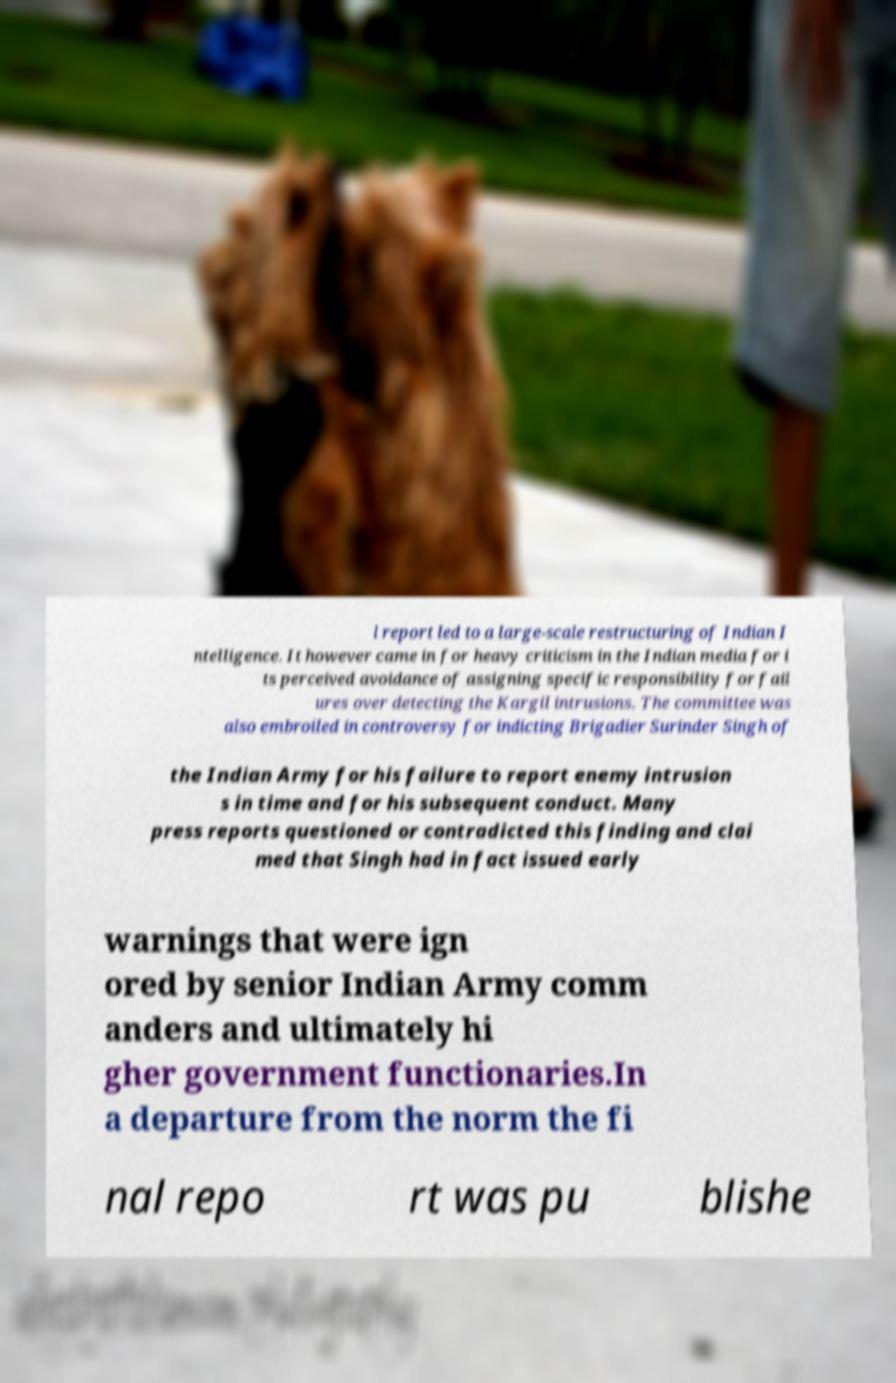I need the written content from this picture converted into text. Can you do that? l report led to a large-scale restructuring of Indian I ntelligence. It however came in for heavy criticism in the Indian media for i ts perceived avoidance of assigning specific responsibility for fail ures over detecting the Kargil intrusions. The committee was also embroiled in controversy for indicting Brigadier Surinder Singh of the Indian Army for his failure to report enemy intrusion s in time and for his subsequent conduct. Many press reports questioned or contradicted this finding and clai med that Singh had in fact issued early warnings that were ign ored by senior Indian Army comm anders and ultimately hi gher government functionaries.In a departure from the norm the fi nal repo rt was pu blishe 